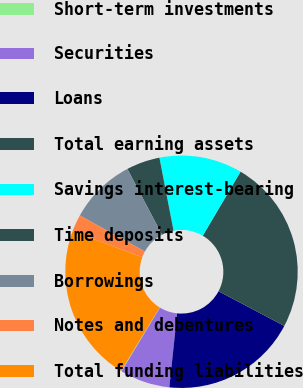Convert chart to OTSL. <chart><loc_0><loc_0><loc_500><loc_500><pie_chart><fcel>Short-term investments<fcel>Securities<fcel>Loans<fcel>Total earning assets<fcel>Savings interest-bearing<fcel>Time deposits<fcel>Borrowings<fcel>Notes and debentures<fcel>Total funding liabilities<nl><fcel>0.1%<fcel>6.95%<fcel>18.95%<fcel>24.24%<fcel>11.53%<fcel>4.67%<fcel>9.24%<fcel>2.38%<fcel>21.95%<nl></chart> 